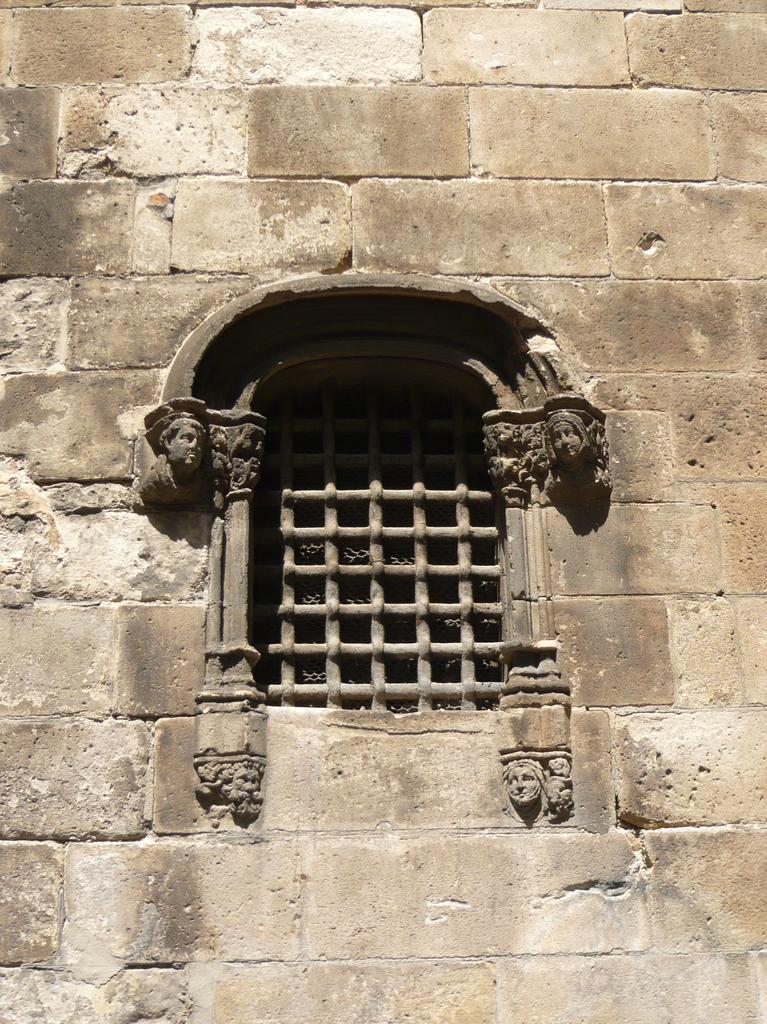Can you describe this image briefly? This picture shows a wall and we see a window. 